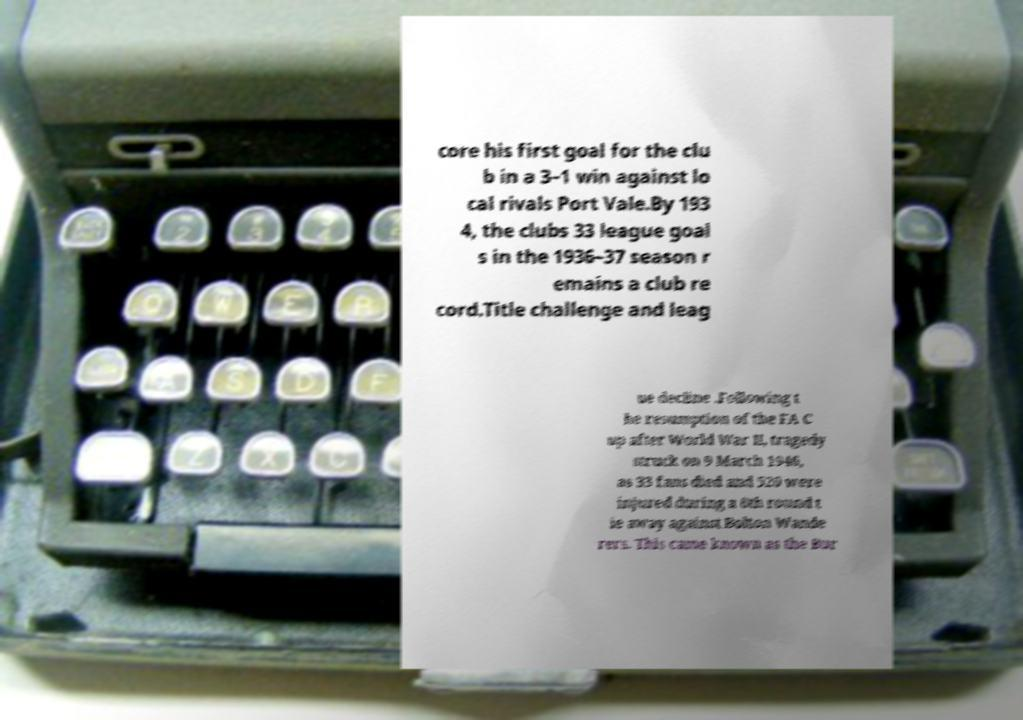For documentation purposes, I need the text within this image transcribed. Could you provide that? core his first goal for the clu b in a 3–1 win against lo cal rivals Port Vale.By 193 4, the clubs 33 league goal s in the 1936–37 season r emains a club re cord.Title challenge and leag ue decline .Following t he resumption of the FA C up after World War II, tragedy struck on 9 March 1946, as 33 fans died and 520 were injured during a 6th round t ie away against Bolton Wande rers. This came known as the Bur 